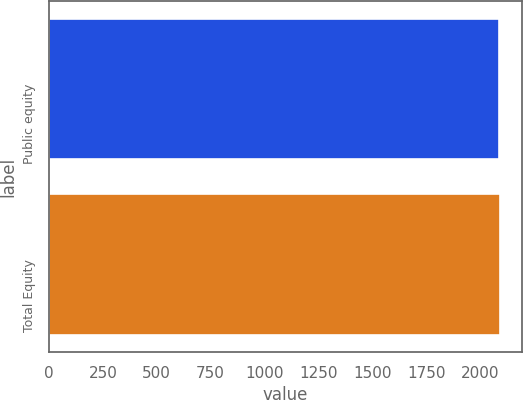Convert chart. <chart><loc_0><loc_0><loc_500><loc_500><bar_chart><fcel>Public equity<fcel>Total Equity<nl><fcel>2089<fcel>2092<nl></chart> 